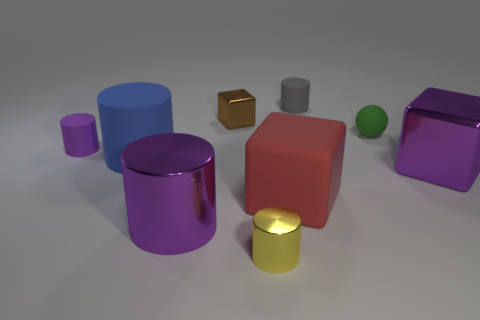Subtract all metal cylinders. How many cylinders are left? 3 Subtract all gray balls. How many purple cylinders are left? 2 Subtract all gray cylinders. How many cylinders are left? 4 Subtract all cylinders. How many objects are left? 4 Subtract 1 red cubes. How many objects are left? 8 Subtract all brown cylinders. Subtract all cyan cubes. How many cylinders are left? 5 Subtract all red matte cubes. Subtract all tiny brown blocks. How many objects are left? 7 Add 1 small purple cylinders. How many small purple cylinders are left? 2 Add 7 large green objects. How many large green objects exist? 7 